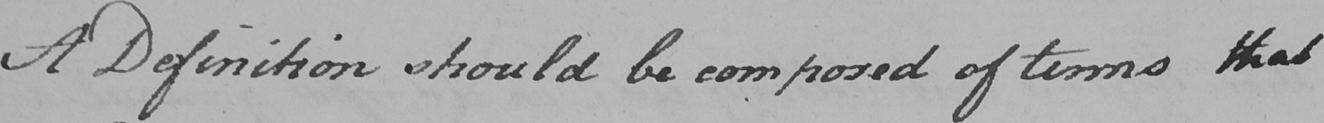Can you read and transcribe this handwriting? A Definition should be composed of terms that 